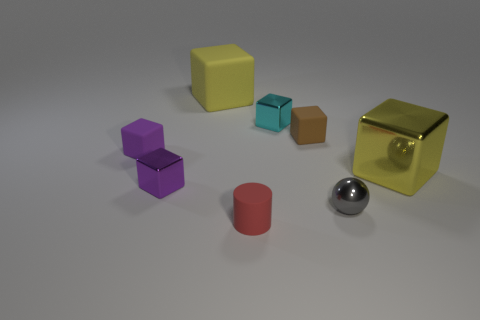Subtract all yellow rubber blocks. How many blocks are left? 5 Subtract all purple blocks. How many blocks are left? 4 Subtract all balls. How many objects are left? 7 Subtract 1 cylinders. How many cylinders are left? 0 Add 2 metallic cubes. How many objects exist? 10 Subtract 0 cyan balls. How many objects are left? 8 Subtract all gray cubes. Subtract all cyan balls. How many cubes are left? 6 Subtract all gray balls. How many brown cubes are left? 1 Subtract all purple matte cubes. Subtract all metal cubes. How many objects are left? 4 Add 2 matte cylinders. How many matte cylinders are left? 3 